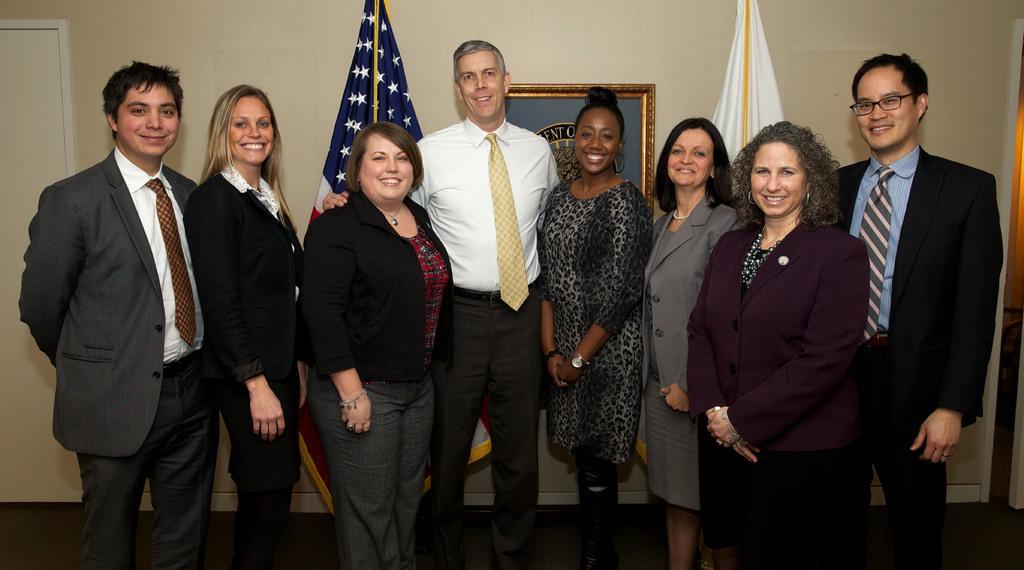Describe this image in one or two sentences. This picture describes about group of people, they are standing and they are all smiling, behind them we can see couple of flags and a frame on the wall. 